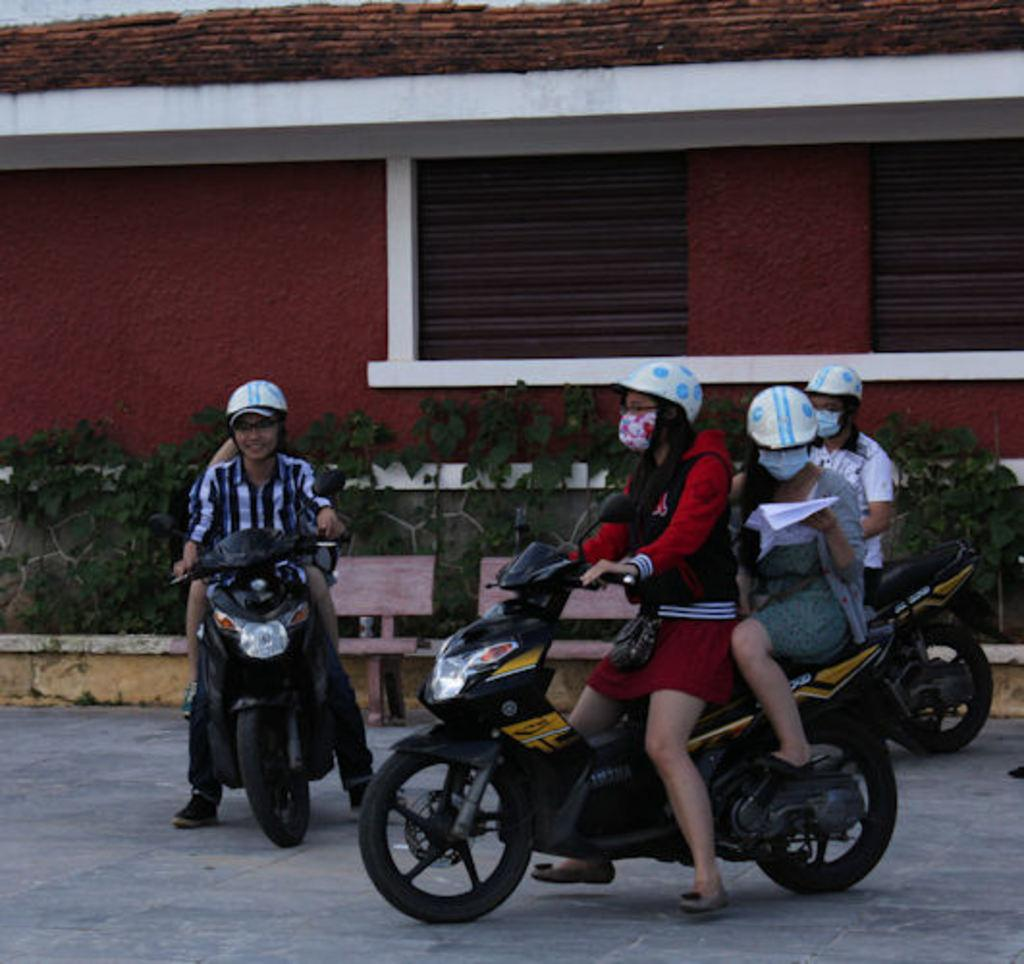How many people are in the image? There are four people in the image. What are the people doing in the image? The people are sitting on motorcycles. What can be seen in the background of the image? There is a red color house in the background. What is in front of the house? There are plants and two benches in front of the house. What type of noise can be heard coming from the tank in the image? There is no tank present in the image, so it's not possible to determine what, if any, noise might be heard. 